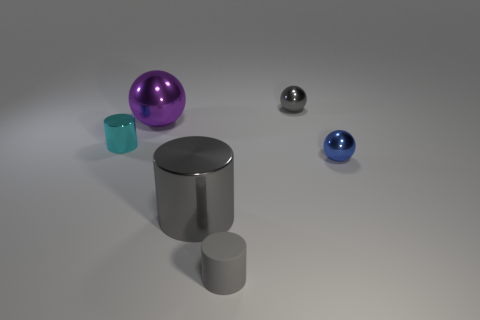Add 3 gray metal things. How many objects exist? 9 Add 5 cylinders. How many cylinders are left? 8 Add 5 cyan metallic cylinders. How many cyan metallic cylinders exist? 6 Subtract 2 gray cylinders. How many objects are left? 4 Subtract all small cyan cylinders. Subtract all tiny cyan things. How many objects are left? 4 